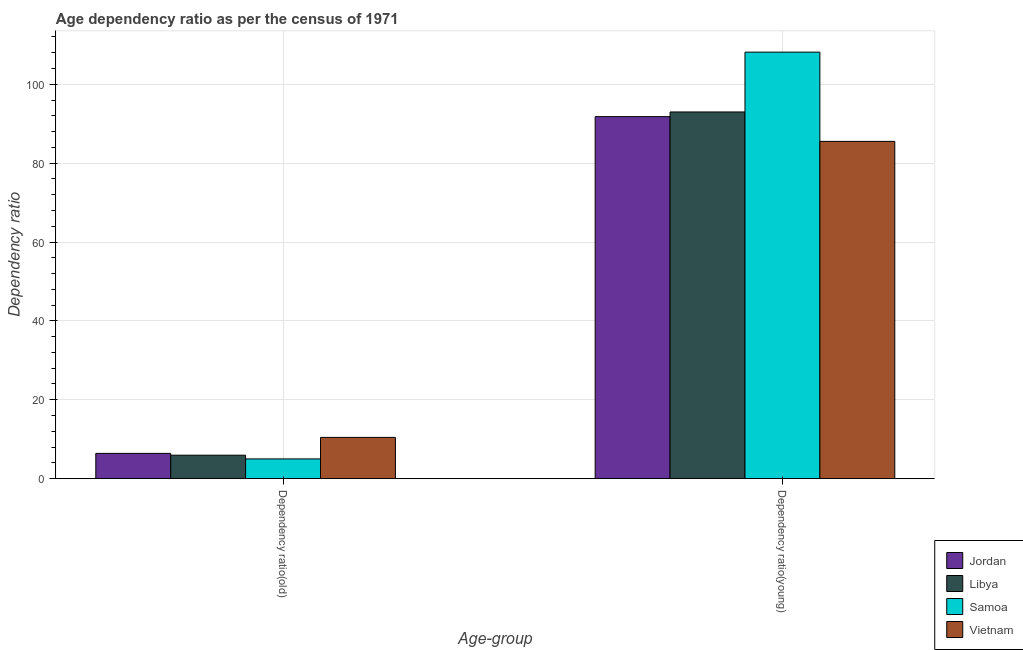How many groups of bars are there?
Ensure brevity in your answer.  2. Are the number of bars per tick equal to the number of legend labels?
Ensure brevity in your answer.  Yes. Are the number of bars on each tick of the X-axis equal?
Your answer should be very brief. Yes. What is the label of the 1st group of bars from the left?
Your answer should be compact. Dependency ratio(old). What is the age dependency ratio(old) in Samoa?
Give a very brief answer. 4.99. Across all countries, what is the maximum age dependency ratio(young)?
Ensure brevity in your answer.  108.16. Across all countries, what is the minimum age dependency ratio(young)?
Ensure brevity in your answer.  85.53. In which country was the age dependency ratio(young) maximum?
Provide a short and direct response. Samoa. In which country was the age dependency ratio(old) minimum?
Your answer should be compact. Samoa. What is the total age dependency ratio(old) in the graph?
Offer a very short reply. 27.78. What is the difference between the age dependency ratio(young) in Jordan and that in Libya?
Offer a terse response. -1.19. What is the difference between the age dependency ratio(old) in Jordan and the age dependency ratio(young) in Samoa?
Your answer should be compact. -101.76. What is the average age dependency ratio(young) per country?
Keep it short and to the point. 94.62. What is the difference between the age dependency ratio(old) and age dependency ratio(young) in Jordan?
Your answer should be compact. -85.41. In how many countries, is the age dependency ratio(young) greater than 20 ?
Your answer should be very brief. 4. What is the ratio of the age dependency ratio(young) in Vietnam to that in Samoa?
Offer a very short reply. 0.79. What does the 1st bar from the left in Dependency ratio(young) represents?
Your answer should be very brief. Jordan. What does the 2nd bar from the right in Dependency ratio(old) represents?
Your response must be concise. Samoa. What is the difference between two consecutive major ticks on the Y-axis?
Give a very brief answer. 20. Where does the legend appear in the graph?
Keep it short and to the point. Bottom right. How are the legend labels stacked?
Offer a very short reply. Vertical. What is the title of the graph?
Keep it short and to the point. Age dependency ratio as per the census of 1971. What is the label or title of the X-axis?
Provide a short and direct response. Age-group. What is the label or title of the Y-axis?
Provide a succinct answer. Dependency ratio. What is the Dependency ratio in Jordan in Dependency ratio(old)?
Offer a very short reply. 6.39. What is the Dependency ratio in Libya in Dependency ratio(old)?
Your answer should be very brief. 5.94. What is the Dependency ratio in Samoa in Dependency ratio(old)?
Your answer should be very brief. 4.99. What is the Dependency ratio of Vietnam in Dependency ratio(old)?
Provide a succinct answer. 10.45. What is the Dependency ratio of Jordan in Dependency ratio(young)?
Your answer should be compact. 91.8. What is the Dependency ratio of Libya in Dependency ratio(young)?
Provide a succinct answer. 92.99. What is the Dependency ratio of Samoa in Dependency ratio(young)?
Offer a very short reply. 108.16. What is the Dependency ratio of Vietnam in Dependency ratio(young)?
Give a very brief answer. 85.53. Across all Age-group, what is the maximum Dependency ratio in Jordan?
Offer a terse response. 91.8. Across all Age-group, what is the maximum Dependency ratio of Libya?
Provide a short and direct response. 92.99. Across all Age-group, what is the maximum Dependency ratio of Samoa?
Make the answer very short. 108.16. Across all Age-group, what is the maximum Dependency ratio of Vietnam?
Make the answer very short. 85.53. Across all Age-group, what is the minimum Dependency ratio in Jordan?
Offer a very short reply. 6.39. Across all Age-group, what is the minimum Dependency ratio of Libya?
Your answer should be very brief. 5.94. Across all Age-group, what is the minimum Dependency ratio of Samoa?
Offer a terse response. 4.99. Across all Age-group, what is the minimum Dependency ratio of Vietnam?
Provide a short and direct response. 10.45. What is the total Dependency ratio of Jordan in the graph?
Your answer should be compact. 98.2. What is the total Dependency ratio in Libya in the graph?
Your answer should be compact. 98.93. What is the total Dependency ratio in Samoa in the graph?
Provide a succinct answer. 113.15. What is the total Dependency ratio in Vietnam in the graph?
Provide a short and direct response. 95.98. What is the difference between the Dependency ratio of Jordan in Dependency ratio(old) and that in Dependency ratio(young)?
Offer a terse response. -85.41. What is the difference between the Dependency ratio of Libya in Dependency ratio(old) and that in Dependency ratio(young)?
Keep it short and to the point. -87.05. What is the difference between the Dependency ratio in Samoa in Dependency ratio(old) and that in Dependency ratio(young)?
Offer a terse response. -103.16. What is the difference between the Dependency ratio in Vietnam in Dependency ratio(old) and that in Dependency ratio(young)?
Provide a succinct answer. -75.07. What is the difference between the Dependency ratio of Jordan in Dependency ratio(old) and the Dependency ratio of Libya in Dependency ratio(young)?
Your answer should be very brief. -86.59. What is the difference between the Dependency ratio of Jordan in Dependency ratio(old) and the Dependency ratio of Samoa in Dependency ratio(young)?
Offer a terse response. -101.76. What is the difference between the Dependency ratio in Jordan in Dependency ratio(old) and the Dependency ratio in Vietnam in Dependency ratio(young)?
Your answer should be compact. -79.13. What is the difference between the Dependency ratio in Libya in Dependency ratio(old) and the Dependency ratio in Samoa in Dependency ratio(young)?
Your answer should be very brief. -102.22. What is the difference between the Dependency ratio in Libya in Dependency ratio(old) and the Dependency ratio in Vietnam in Dependency ratio(young)?
Your response must be concise. -79.59. What is the difference between the Dependency ratio in Samoa in Dependency ratio(old) and the Dependency ratio in Vietnam in Dependency ratio(young)?
Provide a succinct answer. -80.53. What is the average Dependency ratio of Jordan per Age-group?
Your response must be concise. 49.1. What is the average Dependency ratio in Libya per Age-group?
Offer a terse response. 49.46. What is the average Dependency ratio in Samoa per Age-group?
Provide a succinct answer. 56.58. What is the average Dependency ratio of Vietnam per Age-group?
Keep it short and to the point. 47.99. What is the difference between the Dependency ratio of Jordan and Dependency ratio of Libya in Dependency ratio(old)?
Provide a succinct answer. 0.46. What is the difference between the Dependency ratio in Jordan and Dependency ratio in Samoa in Dependency ratio(old)?
Give a very brief answer. 1.4. What is the difference between the Dependency ratio of Jordan and Dependency ratio of Vietnam in Dependency ratio(old)?
Provide a short and direct response. -4.06. What is the difference between the Dependency ratio in Libya and Dependency ratio in Samoa in Dependency ratio(old)?
Give a very brief answer. 0.94. What is the difference between the Dependency ratio of Libya and Dependency ratio of Vietnam in Dependency ratio(old)?
Make the answer very short. -4.52. What is the difference between the Dependency ratio of Samoa and Dependency ratio of Vietnam in Dependency ratio(old)?
Provide a short and direct response. -5.46. What is the difference between the Dependency ratio of Jordan and Dependency ratio of Libya in Dependency ratio(young)?
Provide a succinct answer. -1.19. What is the difference between the Dependency ratio in Jordan and Dependency ratio in Samoa in Dependency ratio(young)?
Your answer should be very brief. -16.36. What is the difference between the Dependency ratio in Jordan and Dependency ratio in Vietnam in Dependency ratio(young)?
Your answer should be very brief. 6.27. What is the difference between the Dependency ratio in Libya and Dependency ratio in Samoa in Dependency ratio(young)?
Provide a succinct answer. -15.17. What is the difference between the Dependency ratio of Libya and Dependency ratio of Vietnam in Dependency ratio(young)?
Ensure brevity in your answer.  7.46. What is the difference between the Dependency ratio in Samoa and Dependency ratio in Vietnam in Dependency ratio(young)?
Make the answer very short. 22.63. What is the ratio of the Dependency ratio in Jordan in Dependency ratio(old) to that in Dependency ratio(young)?
Keep it short and to the point. 0.07. What is the ratio of the Dependency ratio of Libya in Dependency ratio(old) to that in Dependency ratio(young)?
Provide a succinct answer. 0.06. What is the ratio of the Dependency ratio of Samoa in Dependency ratio(old) to that in Dependency ratio(young)?
Your response must be concise. 0.05. What is the ratio of the Dependency ratio of Vietnam in Dependency ratio(old) to that in Dependency ratio(young)?
Offer a very short reply. 0.12. What is the difference between the highest and the second highest Dependency ratio in Jordan?
Give a very brief answer. 85.41. What is the difference between the highest and the second highest Dependency ratio in Libya?
Make the answer very short. 87.05. What is the difference between the highest and the second highest Dependency ratio of Samoa?
Provide a short and direct response. 103.16. What is the difference between the highest and the second highest Dependency ratio of Vietnam?
Provide a short and direct response. 75.07. What is the difference between the highest and the lowest Dependency ratio in Jordan?
Provide a succinct answer. 85.41. What is the difference between the highest and the lowest Dependency ratio of Libya?
Make the answer very short. 87.05. What is the difference between the highest and the lowest Dependency ratio in Samoa?
Ensure brevity in your answer.  103.16. What is the difference between the highest and the lowest Dependency ratio in Vietnam?
Provide a short and direct response. 75.07. 